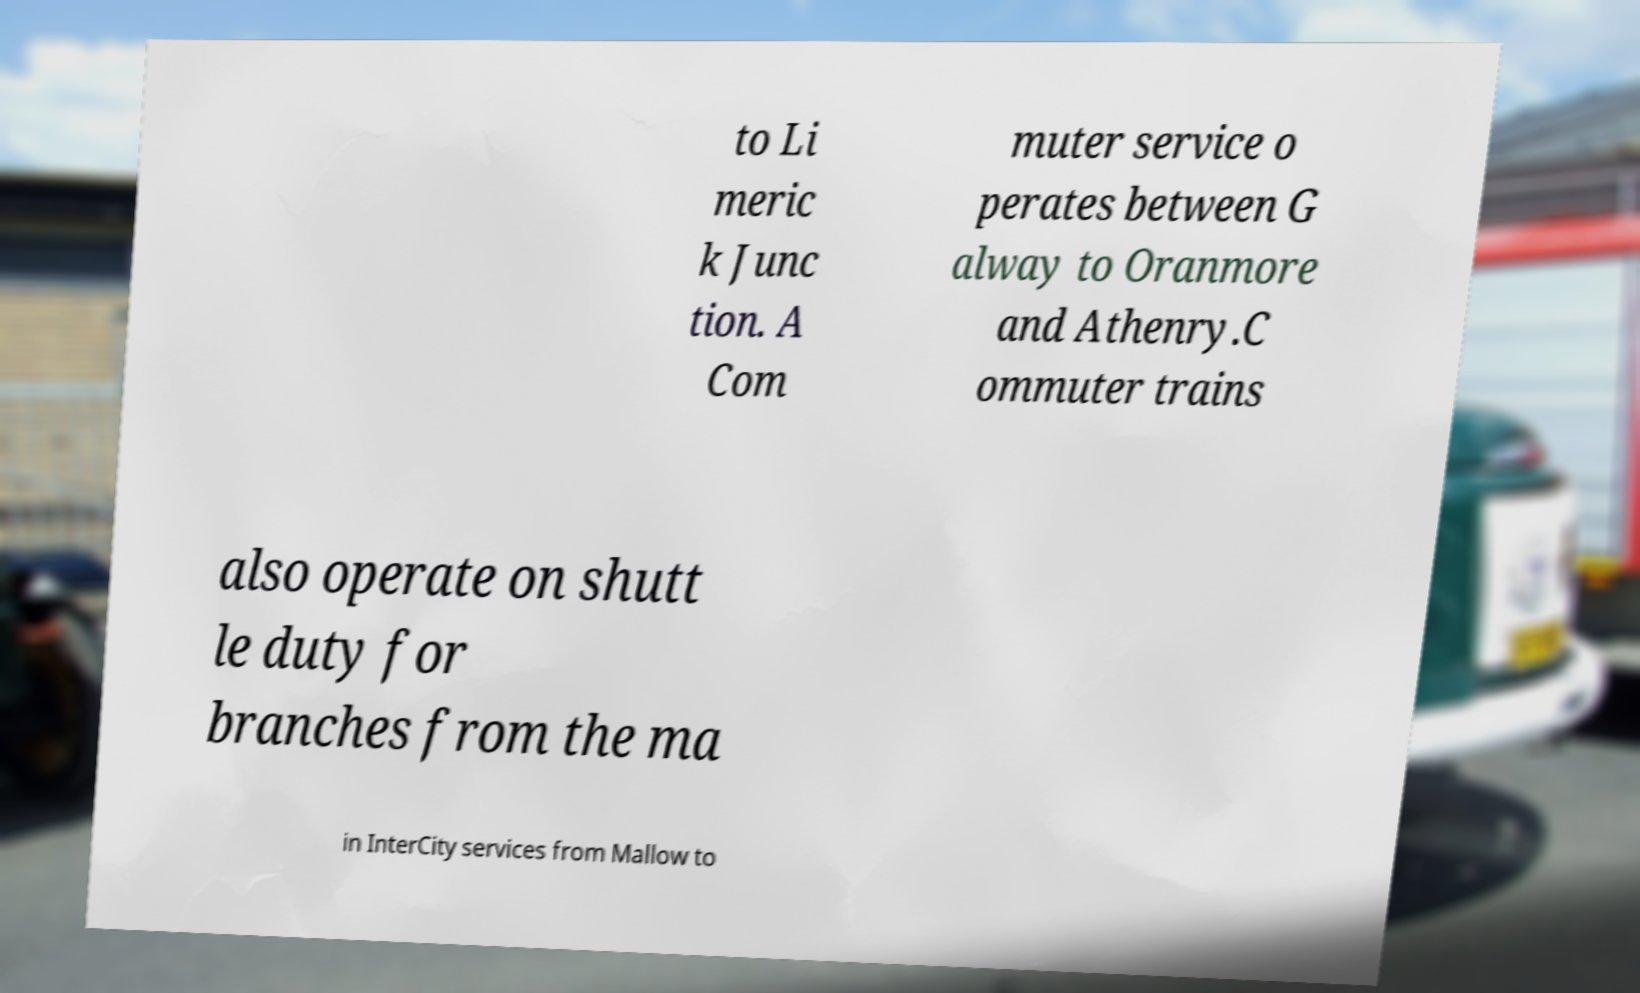Can you read and provide the text displayed in the image?This photo seems to have some interesting text. Can you extract and type it out for me? to Li meric k Junc tion. A Com muter service o perates between G alway to Oranmore and Athenry.C ommuter trains also operate on shutt le duty for branches from the ma in InterCity services from Mallow to 